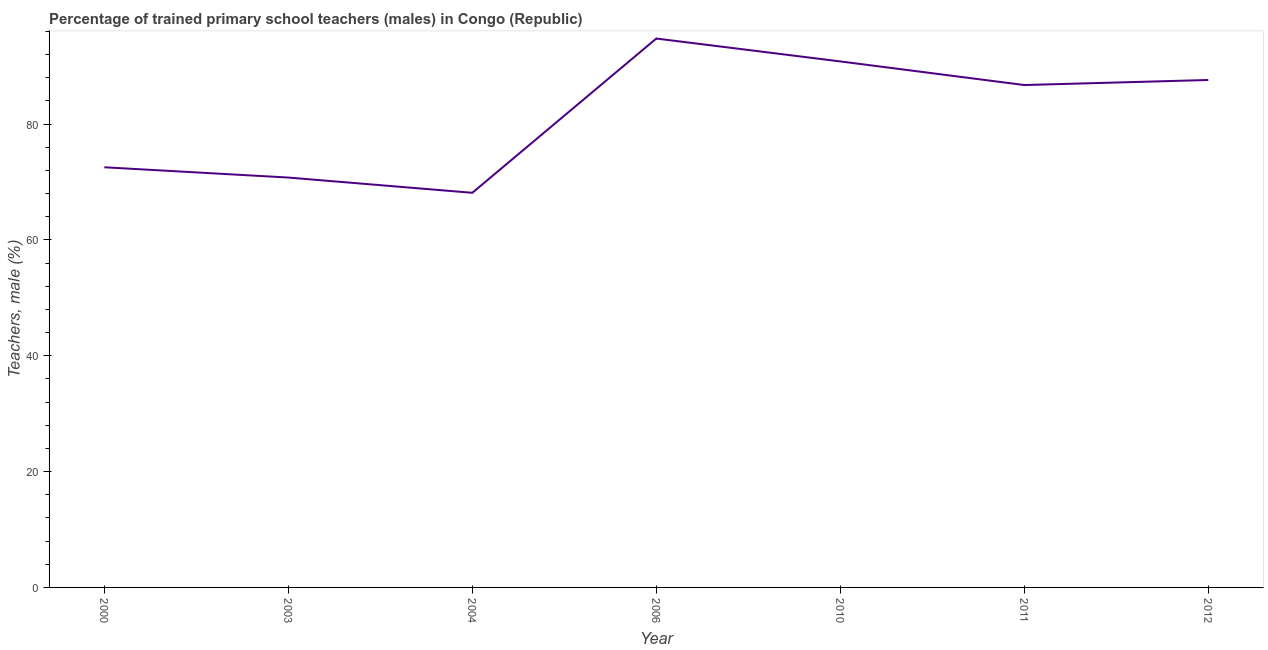What is the percentage of trained male teachers in 2004?
Make the answer very short. 68.13. Across all years, what is the maximum percentage of trained male teachers?
Provide a succinct answer. 94.76. Across all years, what is the minimum percentage of trained male teachers?
Keep it short and to the point. 68.13. In which year was the percentage of trained male teachers maximum?
Offer a very short reply. 2006. What is the sum of the percentage of trained male teachers?
Offer a very short reply. 571.34. What is the difference between the percentage of trained male teachers in 2006 and 2011?
Ensure brevity in your answer.  8.03. What is the average percentage of trained male teachers per year?
Your answer should be compact. 81.62. What is the median percentage of trained male teachers?
Provide a succinct answer. 86.73. In how many years, is the percentage of trained male teachers greater than 8 %?
Provide a short and direct response. 7. Do a majority of the years between 2004 and 2012 (inclusive) have percentage of trained male teachers greater than 44 %?
Provide a succinct answer. Yes. What is the ratio of the percentage of trained male teachers in 2000 to that in 2010?
Your answer should be very brief. 0.8. Is the percentage of trained male teachers in 2003 less than that in 2004?
Provide a succinct answer. No. What is the difference between the highest and the second highest percentage of trained male teachers?
Your response must be concise. 3.95. Is the sum of the percentage of trained male teachers in 2006 and 2011 greater than the maximum percentage of trained male teachers across all years?
Your answer should be compact. Yes. What is the difference between the highest and the lowest percentage of trained male teachers?
Offer a very short reply. 26.63. How many years are there in the graph?
Make the answer very short. 7. Are the values on the major ticks of Y-axis written in scientific E-notation?
Provide a short and direct response. No. Does the graph contain any zero values?
Give a very brief answer. No. Does the graph contain grids?
Ensure brevity in your answer.  No. What is the title of the graph?
Provide a succinct answer. Percentage of trained primary school teachers (males) in Congo (Republic). What is the label or title of the Y-axis?
Keep it short and to the point. Teachers, male (%). What is the Teachers, male (%) of 2000?
Make the answer very short. 72.54. What is the Teachers, male (%) of 2003?
Give a very brief answer. 70.76. What is the Teachers, male (%) of 2004?
Give a very brief answer. 68.13. What is the Teachers, male (%) of 2006?
Your response must be concise. 94.76. What is the Teachers, male (%) of 2010?
Offer a terse response. 90.81. What is the Teachers, male (%) in 2011?
Your answer should be compact. 86.73. What is the Teachers, male (%) in 2012?
Provide a short and direct response. 87.61. What is the difference between the Teachers, male (%) in 2000 and 2003?
Ensure brevity in your answer.  1.78. What is the difference between the Teachers, male (%) in 2000 and 2004?
Provide a short and direct response. 4.41. What is the difference between the Teachers, male (%) in 2000 and 2006?
Your answer should be compact. -22.23. What is the difference between the Teachers, male (%) in 2000 and 2010?
Provide a short and direct response. -18.27. What is the difference between the Teachers, male (%) in 2000 and 2011?
Your answer should be very brief. -14.2. What is the difference between the Teachers, male (%) in 2000 and 2012?
Make the answer very short. -15.07. What is the difference between the Teachers, male (%) in 2003 and 2004?
Offer a very short reply. 2.63. What is the difference between the Teachers, male (%) in 2003 and 2006?
Your answer should be very brief. -24. What is the difference between the Teachers, male (%) in 2003 and 2010?
Provide a short and direct response. -20.05. What is the difference between the Teachers, male (%) in 2003 and 2011?
Provide a succinct answer. -15.97. What is the difference between the Teachers, male (%) in 2003 and 2012?
Your answer should be very brief. -16.84. What is the difference between the Teachers, male (%) in 2004 and 2006?
Your answer should be very brief. -26.63. What is the difference between the Teachers, male (%) in 2004 and 2010?
Give a very brief answer. -22.68. What is the difference between the Teachers, male (%) in 2004 and 2011?
Provide a short and direct response. -18.6. What is the difference between the Teachers, male (%) in 2004 and 2012?
Provide a short and direct response. -19.48. What is the difference between the Teachers, male (%) in 2006 and 2010?
Provide a short and direct response. 3.95. What is the difference between the Teachers, male (%) in 2006 and 2011?
Your response must be concise. 8.03. What is the difference between the Teachers, male (%) in 2006 and 2012?
Your answer should be very brief. 7.16. What is the difference between the Teachers, male (%) in 2010 and 2011?
Your answer should be compact. 4.08. What is the difference between the Teachers, male (%) in 2010 and 2012?
Offer a terse response. 3.2. What is the difference between the Teachers, male (%) in 2011 and 2012?
Make the answer very short. -0.87. What is the ratio of the Teachers, male (%) in 2000 to that in 2003?
Keep it short and to the point. 1.02. What is the ratio of the Teachers, male (%) in 2000 to that in 2004?
Offer a very short reply. 1.06. What is the ratio of the Teachers, male (%) in 2000 to that in 2006?
Your answer should be very brief. 0.77. What is the ratio of the Teachers, male (%) in 2000 to that in 2010?
Keep it short and to the point. 0.8. What is the ratio of the Teachers, male (%) in 2000 to that in 2011?
Provide a succinct answer. 0.84. What is the ratio of the Teachers, male (%) in 2000 to that in 2012?
Ensure brevity in your answer.  0.83. What is the ratio of the Teachers, male (%) in 2003 to that in 2004?
Your answer should be very brief. 1.04. What is the ratio of the Teachers, male (%) in 2003 to that in 2006?
Offer a very short reply. 0.75. What is the ratio of the Teachers, male (%) in 2003 to that in 2010?
Give a very brief answer. 0.78. What is the ratio of the Teachers, male (%) in 2003 to that in 2011?
Ensure brevity in your answer.  0.82. What is the ratio of the Teachers, male (%) in 2003 to that in 2012?
Make the answer very short. 0.81. What is the ratio of the Teachers, male (%) in 2004 to that in 2006?
Your answer should be very brief. 0.72. What is the ratio of the Teachers, male (%) in 2004 to that in 2010?
Your response must be concise. 0.75. What is the ratio of the Teachers, male (%) in 2004 to that in 2011?
Provide a succinct answer. 0.79. What is the ratio of the Teachers, male (%) in 2004 to that in 2012?
Provide a short and direct response. 0.78. What is the ratio of the Teachers, male (%) in 2006 to that in 2010?
Keep it short and to the point. 1.04. What is the ratio of the Teachers, male (%) in 2006 to that in 2011?
Make the answer very short. 1.09. What is the ratio of the Teachers, male (%) in 2006 to that in 2012?
Give a very brief answer. 1.08. What is the ratio of the Teachers, male (%) in 2010 to that in 2011?
Make the answer very short. 1.05. What is the ratio of the Teachers, male (%) in 2010 to that in 2012?
Your answer should be very brief. 1.04. What is the ratio of the Teachers, male (%) in 2011 to that in 2012?
Offer a very short reply. 0.99. 